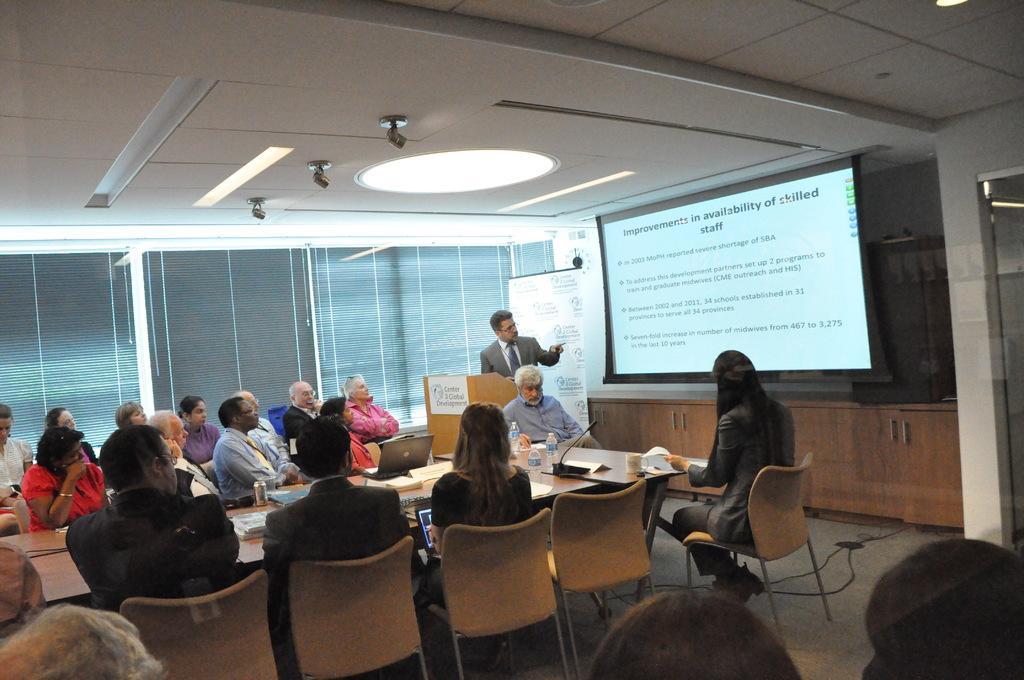Please provide a concise description of this image. In this picture we can see a group of people sitting on chairs. In front of the people there is a table and on the table there are bottles, papers, a microphone, laptop and some objects. A man is standing behind the podium. Behind the man there is a banner, projector screen and cupboards. At the top there are lights. 